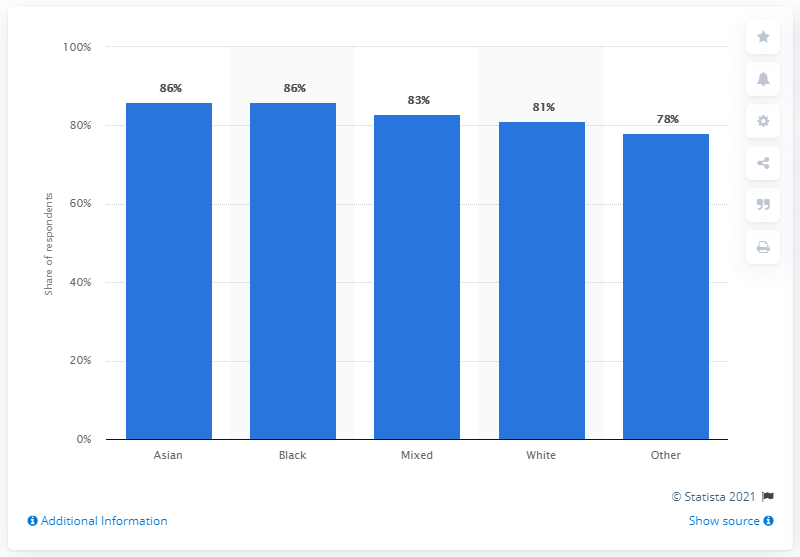Outline some significant characteristics in this image. According to a recent survey, an overwhelming 86% of the population believed that their local area was a place where people from different backgrounds get along well with each other. 